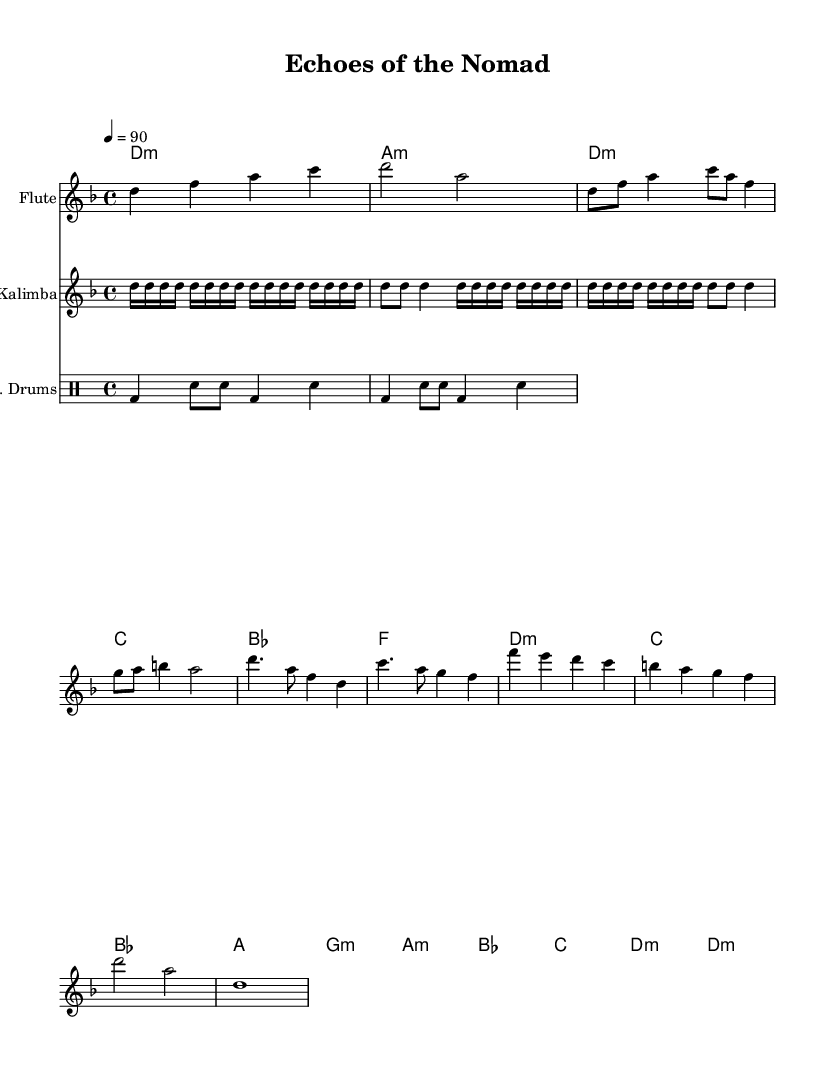What is the key signature of this music? The key signature is D minor, which includes one flat (B flat). This can be identified from the key signature indicated at the beginning of the staff.
Answer: D minor What is the time signature of this music? The time signature is 4/4, which is indicated at the beginning of the piece. It means there are four beats in each measure and the quarter note receives one beat.
Answer: 4/4 What is the tempo marking of this piece? The tempo marking is 90 beats per minute, which means the piece is set to play at this speed. It is written as "4 = 90" at the start of the score.
Answer: 90 How many measures does the flute part have? The flute part has 8 measures, which can be counted by looking at the number of vertical lines separating the notes in the flute staff.
Answer: 8 What is the first chord played in the harmonies? The first chord in the harmonies is D minor, which is indicated at the beginning of the chord section. It is written as "d1:m".
Answer: D minor Which instrument has a repeating motif? The kalimba has a repeating motif, which is observed by the repeated figure in the score indicated by the "repeat unfold" notation.
Answer: Kalimba What type of drums are used in this piece? The piece uses electronic drums, as indicated by "E. Drums" at the beginning of the drum staff. This suggests a modern twist on traditional rhythms and beats.
Answer: Electronic drums 